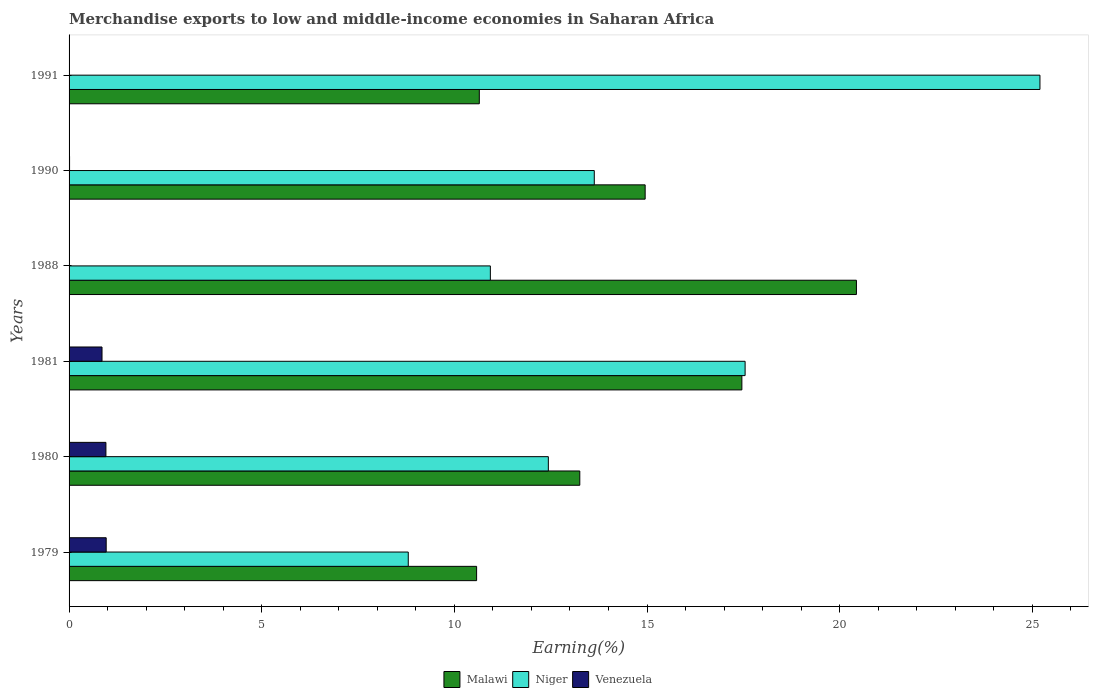Are the number of bars per tick equal to the number of legend labels?
Make the answer very short. Yes. What is the label of the 2nd group of bars from the top?
Ensure brevity in your answer.  1990. In how many cases, is the number of bars for a given year not equal to the number of legend labels?
Give a very brief answer. 0. What is the percentage of amount earned from merchandise exports in Niger in 1979?
Offer a terse response. 8.8. Across all years, what is the maximum percentage of amount earned from merchandise exports in Venezuela?
Your response must be concise. 0.96. Across all years, what is the minimum percentage of amount earned from merchandise exports in Niger?
Keep it short and to the point. 8.8. In which year was the percentage of amount earned from merchandise exports in Niger maximum?
Your response must be concise. 1991. In which year was the percentage of amount earned from merchandise exports in Niger minimum?
Provide a succinct answer. 1979. What is the total percentage of amount earned from merchandise exports in Venezuela in the graph?
Keep it short and to the point. 2.79. What is the difference between the percentage of amount earned from merchandise exports in Niger in 1980 and that in 1991?
Your answer should be very brief. -12.76. What is the difference between the percentage of amount earned from merchandise exports in Venezuela in 1990 and the percentage of amount earned from merchandise exports in Malawi in 1991?
Provide a short and direct response. -10.63. What is the average percentage of amount earned from merchandise exports in Venezuela per year?
Give a very brief answer. 0.46. In the year 1991, what is the difference between the percentage of amount earned from merchandise exports in Venezuela and percentage of amount earned from merchandise exports in Malawi?
Your answer should be very brief. -10.65. In how many years, is the percentage of amount earned from merchandise exports in Venezuela greater than 20 %?
Offer a very short reply. 0. What is the ratio of the percentage of amount earned from merchandise exports in Niger in 1980 to that in 1988?
Provide a short and direct response. 1.14. Is the percentage of amount earned from merchandise exports in Venezuela in 1979 less than that in 1988?
Ensure brevity in your answer.  No. Is the difference between the percentage of amount earned from merchandise exports in Venezuela in 1988 and 1991 greater than the difference between the percentage of amount earned from merchandise exports in Malawi in 1988 and 1991?
Keep it short and to the point. No. What is the difference between the highest and the second highest percentage of amount earned from merchandise exports in Niger?
Make the answer very short. 7.65. What is the difference between the highest and the lowest percentage of amount earned from merchandise exports in Niger?
Make the answer very short. 16.39. Is the sum of the percentage of amount earned from merchandise exports in Malawi in 1981 and 1988 greater than the maximum percentage of amount earned from merchandise exports in Venezuela across all years?
Offer a very short reply. Yes. What does the 2nd bar from the top in 1988 represents?
Provide a short and direct response. Niger. What does the 1st bar from the bottom in 1981 represents?
Give a very brief answer. Malawi. Is it the case that in every year, the sum of the percentage of amount earned from merchandise exports in Malawi and percentage of amount earned from merchandise exports in Venezuela is greater than the percentage of amount earned from merchandise exports in Niger?
Your answer should be very brief. No. How many bars are there?
Your answer should be very brief. 18. Does the graph contain any zero values?
Keep it short and to the point. No. Does the graph contain grids?
Keep it short and to the point. No. Where does the legend appear in the graph?
Offer a terse response. Bottom center. What is the title of the graph?
Offer a terse response. Merchandise exports to low and middle-income economies in Saharan Africa. What is the label or title of the X-axis?
Offer a very short reply. Earning(%). What is the label or title of the Y-axis?
Make the answer very short. Years. What is the Earning(%) of Malawi in 1979?
Make the answer very short. 10.58. What is the Earning(%) of Niger in 1979?
Keep it short and to the point. 8.8. What is the Earning(%) of Venezuela in 1979?
Give a very brief answer. 0.96. What is the Earning(%) of Malawi in 1980?
Keep it short and to the point. 13.26. What is the Earning(%) of Niger in 1980?
Offer a very short reply. 12.44. What is the Earning(%) in Venezuela in 1980?
Make the answer very short. 0.96. What is the Earning(%) of Malawi in 1981?
Offer a terse response. 17.46. What is the Earning(%) in Niger in 1981?
Ensure brevity in your answer.  17.55. What is the Earning(%) in Venezuela in 1981?
Give a very brief answer. 0.85. What is the Earning(%) of Malawi in 1988?
Offer a very short reply. 20.44. What is the Earning(%) in Niger in 1988?
Provide a short and direct response. 10.93. What is the Earning(%) of Venezuela in 1988?
Offer a very short reply. 0. What is the Earning(%) in Malawi in 1990?
Your answer should be compact. 14.95. What is the Earning(%) in Niger in 1990?
Offer a very short reply. 13.63. What is the Earning(%) of Venezuela in 1990?
Your answer should be very brief. 0.01. What is the Earning(%) of Malawi in 1991?
Keep it short and to the point. 10.65. What is the Earning(%) in Niger in 1991?
Provide a short and direct response. 25.2. What is the Earning(%) in Venezuela in 1991?
Provide a succinct answer. 0. Across all years, what is the maximum Earning(%) in Malawi?
Ensure brevity in your answer.  20.44. Across all years, what is the maximum Earning(%) in Niger?
Your answer should be compact. 25.2. Across all years, what is the maximum Earning(%) of Venezuela?
Your answer should be very brief. 0.96. Across all years, what is the minimum Earning(%) of Malawi?
Your response must be concise. 10.58. Across all years, what is the minimum Earning(%) in Niger?
Offer a very short reply. 8.8. Across all years, what is the minimum Earning(%) in Venezuela?
Offer a very short reply. 0. What is the total Earning(%) of Malawi in the graph?
Ensure brevity in your answer.  87.33. What is the total Earning(%) of Niger in the graph?
Offer a very short reply. 88.55. What is the total Earning(%) in Venezuela in the graph?
Your answer should be very brief. 2.79. What is the difference between the Earning(%) of Malawi in 1979 and that in 1980?
Provide a succinct answer. -2.68. What is the difference between the Earning(%) of Niger in 1979 and that in 1980?
Ensure brevity in your answer.  -3.64. What is the difference between the Earning(%) in Venezuela in 1979 and that in 1980?
Provide a succinct answer. 0.01. What is the difference between the Earning(%) of Malawi in 1979 and that in 1981?
Your answer should be very brief. -6.88. What is the difference between the Earning(%) of Niger in 1979 and that in 1981?
Provide a short and direct response. -8.74. What is the difference between the Earning(%) of Venezuela in 1979 and that in 1981?
Make the answer very short. 0.11. What is the difference between the Earning(%) of Malawi in 1979 and that in 1988?
Give a very brief answer. -9.86. What is the difference between the Earning(%) in Niger in 1979 and that in 1988?
Offer a terse response. -2.13. What is the difference between the Earning(%) in Venezuela in 1979 and that in 1988?
Offer a very short reply. 0.96. What is the difference between the Earning(%) in Malawi in 1979 and that in 1990?
Provide a short and direct response. -4.37. What is the difference between the Earning(%) of Niger in 1979 and that in 1990?
Keep it short and to the point. -4.83. What is the difference between the Earning(%) in Venezuela in 1979 and that in 1990?
Ensure brevity in your answer.  0.95. What is the difference between the Earning(%) in Malawi in 1979 and that in 1991?
Your response must be concise. -0.07. What is the difference between the Earning(%) of Niger in 1979 and that in 1991?
Keep it short and to the point. -16.39. What is the difference between the Earning(%) in Venezuela in 1979 and that in 1991?
Offer a terse response. 0.96. What is the difference between the Earning(%) of Malawi in 1980 and that in 1981?
Offer a terse response. -4.21. What is the difference between the Earning(%) of Niger in 1980 and that in 1981?
Make the answer very short. -5.11. What is the difference between the Earning(%) in Venezuela in 1980 and that in 1981?
Provide a short and direct response. 0.1. What is the difference between the Earning(%) of Malawi in 1980 and that in 1988?
Your answer should be very brief. -7.18. What is the difference between the Earning(%) in Niger in 1980 and that in 1988?
Your answer should be compact. 1.51. What is the difference between the Earning(%) of Venezuela in 1980 and that in 1988?
Offer a terse response. 0.96. What is the difference between the Earning(%) in Malawi in 1980 and that in 1990?
Ensure brevity in your answer.  -1.7. What is the difference between the Earning(%) of Niger in 1980 and that in 1990?
Keep it short and to the point. -1.19. What is the difference between the Earning(%) in Venezuela in 1980 and that in 1990?
Make the answer very short. 0.94. What is the difference between the Earning(%) in Malawi in 1980 and that in 1991?
Provide a succinct answer. 2.61. What is the difference between the Earning(%) in Niger in 1980 and that in 1991?
Your answer should be very brief. -12.76. What is the difference between the Earning(%) of Venezuela in 1980 and that in 1991?
Give a very brief answer. 0.96. What is the difference between the Earning(%) in Malawi in 1981 and that in 1988?
Give a very brief answer. -2.97. What is the difference between the Earning(%) in Niger in 1981 and that in 1988?
Your answer should be compact. 6.61. What is the difference between the Earning(%) of Venezuela in 1981 and that in 1988?
Your response must be concise. 0.85. What is the difference between the Earning(%) in Malawi in 1981 and that in 1990?
Your answer should be compact. 2.51. What is the difference between the Earning(%) in Niger in 1981 and that in 1990?
Provide a short and direct response. 3.91. What is the difference between the Earning(%) in Venezuela in 1981 and that in 1990?
Keep it short and to the point. 0.84. What is the difference between the Earning(%) in Malawi in 1981 and that in 1991?
Your answer should be compact. 6.81. What is the difference between the Earning(%) in Niger in 1981 and that in 1991?
Make the answer very short. -7.65. What is the difference between the Earning(%) of Venezuela in 1981 and that in 1991?
Ensure brevity in your answer.  0.85. What is the difference between the Earning(%) of Malawi in 1988 and that in 1990?
Give a very brief answer. 5.48. What is the difference between the Earning(%) in Niger in 1988 and that in 1990?
Your answer should be compact. -2.7. What is the difference between the Earning(%) in Venezuela in 1988 and that in 1990?
Make the answer very short. -0.01. What is the difference between the Earning(%) in Malawi in 1988 and that in 1991?
Make the answer very short. 9.79. What is the difference between the Earning(%) in Niger in 1988 and that in 1991?
Make the answer very short. -14.26. What is the difference between the Earning(%) in Venezuela in 1988 and that in 1991?
Keep it short and to the point. -0. What is the difference between the Earning(%) in Malawi in 1990 and that in 1991?
Give a very brief answer. 4.3. What is the difference between the Earning(%) of Niger in 1990 and that in 1991?
Ensure brevity in your answer.  -11.57. What is the difference between the Earning(%) of Venezuela in 1990 and that in 1991?
Your answer should be very brief. 0.01. What is the difference between the Earning(%) of Malawi in 1979 and the Earning(%) of Niger in 1980?
Offer a very short reply. -1.86. What is the difference between the Earning(%) of Malawi in 1979 and the Earning(%) of Venezuela in 1980?
Offer a terse response. 9.62. What is the difference between the Earning(%) of Niger in 1979 and the Earning(%) of Venezuela in 1980?
Your response must be concise. 7.85. What is the difference between the Earning(%) of Malawi in 1979 and the Earning(%) of Niger in 1981?
Ensure brevity in your answer.  -6.97. What is the difference between the Earning(%) of Malawi in 1979 and the Earning(%) of Venezuela in 1981?
Provide a succinct answer. 9.72. What is the difference between the Earning(%) in Niger in 1979 and the Earning(%) in Venezuela in 1981?
Your answer should be very brief. 7.95. What is the difference between the Earning(%) in Malawi in 1979 and the Earning(%) in Niger in 1988?
Provide a succinct answer. -0.36. What is the difference between the Earning(%) of Malawi in 1979 and the Earning(%) of Venezuela in 1988?
Your answer should be very brief. 10.58. What is the difference between the Earning(%) in Niger in 1979 and the Earning(%) in Venezuela in 1988?
Make the answer very short. 8.8. What is the difference between the Earning(%) of Malawi in 1979 and the Earning(%) of Niger in 1990?
Offer a terse response. -3.05. What is the difference between the Earning(%) of Malawi in 1979 and the Earning(%) of Venezuela in 1990?
Your answer should be very brief. 10.56. What is the difference between the Earning(%) of Niger in 1979 and the Earning(%) of Venezuela in 1990?
Provide a short and direct response. 8.79. What is the difference between the Earning(%) of Malawi in 1979 and the Earning(%) of Niger in 1991?
Your answer should be compact. -14.62. What is the difference between the Earning(%) in Malawi in 1979 and the Earning(%) in Venezuela in 1991?
Provide a short and direct response. 10.58. What is the difference between the Earning(%) in Niger in 1979 and the Earning(%) in Venezuela in 1991?
Keep it short and to the point. 8.8. What is the difference between the Earning(%) of Malawi in 1980 and the Earning(%) of Niger in 1981?
Offer a terse response. -4.29. What is the difference between the Earning(%) in Malawi in 1980 and the Earning(%) in Venezuela in 1981?
Provide a short and direct response. 12.4. What is the difference between the Earning(%) in Niger in 1980 and the Earning(%) in Venezuela in 1981?
Make the answer very short. 11.58. What is the difference between the Earning(%) in Malawi in 1980 and the Earning(%) in Niger in 1988?
Make the answer very short. 2.32. What is the difference between the Earning(%) of Malawi in 1980 and the Earning(%) of Venezuela in 1988?
Your answer should be very brief. 13.26. What is the difference between the Earning(%) in Niger in 1980 and the Earning(%) in Venezuela in 1988?
Keep it short and to the point. 12.44. What is the difference between the Earning(%) in Malawi in 1980 and the Earning(%) in Niger in 1990?
Your answer should be compact. -0.38. What is the difference between the Earning(%) of Malawi in 1980 and the Earning(%) of Venezuela in 1990?
Your answer should be very brief. 13.24. What is the difference between the Earning(%) of Niger in 1980 and the Earning(%) of Venezuela in 1990?
Provide a short and direct response. 12.43. What is the difference between the Earning(%) in Malawi in 1980 and the Earning(%) in Niger in 1991?
Your response must be concise. -11.94. What is the difference between the Earning(%) of Malawi in 1980 and the Earning(%) of Venezuela in 1991?
Make the answer very short. 13.26. What is the difference between the Earning(%) of Niger in 1980 and the Earning(%) of Venezuela in 1991?
Make the answer very short. 12.44. What is the difference between the Earning(%) in Malawi in 1981 and the Earning(%) in Niger in 1988?
Provide a short and direct response. 6.53. What is the difference between the Earning(%) in Malawi in 1981 and the Earning(%) in Venezuela in 1988?
Your response must be concise. 17.46. What is the difference between the Earning(%) in Niger in 1981 and the Earning(%) in Venezuela in 1988?
Your response must be concise. 17.55. What is the difference between the Earning(%) in Malawi in 1981 and the Earning(%) in Niger in 1990?
Your response must be concise. 3.83. What is the difference between the Earning(%) in Malawi in 1981 and the Earning(%) in Venezuela in 1990?
Give a very brief answer. 17.45. What is the difference between the Earning(%) in Niger in 1981 and the Earning(%) in Venezuela in 1990?
Your answer should be very brief. 17.53. What is the difference between the Earning(%) of Malawi in 1981 and the Earning(%) of Niger in 1991?
Keep it short and to the point. -7.74. What is the difference between the Earning(%) of Malawi in 1981 and the Earning(%) of Venezuela in 1991?
Make the answer very short. 17.46. What is the difference between the Earning(%) in Niger in 1981 and the Earning(%) in Venezuela in 1991?
Ensure brevity in your answer.  17.55. What is the difference between the Earning(%) in Malawi in 1988 and the Earning(%) in Niger in 1990?
Keep it short and to the point. 6.8. What is the difference between the Earning(%) of Malawi in 1988 and the Earning(%) of Venezuela in 1990?
Keep it short and to the point. 20.42. What is the difference between the Earning(%) of Niger in 1988 and the Earning(%) of Venezuela in 1990?
Offer a very short reply. 10.92. What is the difference between the Earning(%) of Malawi in 1988 and the Earning(%) of Niger in 1991?
Your answer should be very brief. -4.76. What is the difference between the Earning(%) of Malawi in 1988 and the Earning(%) of Venezuela in 1991?
Your answer should be compact. 20.44. What is the difference between the Earning(%) in Niger in 1988 and the Earning(%) in Venezuela in 1991?
Give a very brief answer. 10.93. What is the difference between the Earning(%) of Malawi in 1990 and the Earning(%) of Niger in 1991?
Ensure brevity in your answer.  -10.25. What is the difference between the Earning(%) in Malawi in 1990 and the Earning(%) in Venezuela in 1991?
Make the answer very short. 14.95. What is the difference between the Earning(%) of Niger in 1990 and the Earning(%) of Venezuela in 1991?
Provide a short and direct response. 13.63. What is the average Earning(%) in Malawi per year?
Keep it short and to the point. 14.55. What is the average Earning(%) in Niger per year?
Ensure brevity in your answer.  14.76. What is the average Earning(%) in Venezuela per year?
Offer a terse response. 0.46. In the year 1979, what is the difference between the Earning(%) in Malawi and Earning(%) in Niger?
Your response must be concise. 1.77. In the year 1979, what is the difference between the Earning(%) of Malawi and Earning(%) of Venezuela?
Offer a very short reply. 9.61. In the year 1979, what is the difference between the Earning(%) of Niger and Earning(%) of Venezuela?
Your answer should be very brief. 7.84. In the year 1980, what is the difference between the Earning(%) in Malawi and Earning(%) in Niger?
Make the answer very short. 0.82. In the year 1980, what is the difference between the Earning(%) in Malawi and Earning(%) in Venezuela?
Make the answer very short. 12.3. In the year 1980, what is the difference between the Earning(%) in Niger and Earning(%) in Venezuela?
Offer a very short reply. 11.48. In the year 1981, what is the difference between the Earning(%) in Malawi and Earning(%) in Niger?
Your answer should be very brief. -0.08. In the year 1981, what is the difference between the Earning(%) of Malawi and Earning(%) of Venezuela?
Give a very brief answer. 16.61. In the year 1981, what is the difference between the Earning(%) of Niger and Earning(%) of Venezuela?
Your answer should be compact. 16.69. In the year 1988, what is the difference between the Earning(%) in Malawi and Earning(%) in Niger?
Ensure brevity in your answer.  9.5. In the year 1988, what is the difference between the Earning(%) in Malawi and Earning(%) in Venezuela?
Give a very brief answer. 20.44. In the year 1988, what is the difference between the Earning(%) in Niger and Earning(%) in Venezuela?
Keep it short and to the point. 10.93. In the year 1990, what is the difference between the Earning(%) in Malawi and Earning(%) in Niger?
Offer a terse response. 1.32. In the year 1990, what is the difference between the Earning(%) in Malawi and Earning(%) in Venezuela?
Provide a succinct answer. 14.94. In the year 1990, what is the difference between the Earning(%) of Niger and Earning(%) of Venezuela?
Your response must be concise. 13.62. In the year 1991, what is the difference between the Earning(%) of Malawi and Earning(%) of Niger?
Provide a short and direct response. -14.55. In the year 1991, what is the difference between the Earning(%) of Malawi and Earning(%) of Venezuela?
Make the answer very short. 10.65. In the year 1991, what is the difference between the Earning(%) of Niger and Earning(%) of Venezuela?
Your answer should be compact. 25.2. What is the ratio of the Earning(%) in Malawi in 1979 to that in 1980?
Give a very brief answer. 0.8. What is the ratio of the Earning(%) of Niger in 1979 to that in 1980?
Provide a succinct answer. 0.71. What is the ratio of the Earning(%) of Venezuela in 1979 to that in 1980?
Provide a succinct answer. 1.01. What is the ratio of the Earning(%) in Malawi in 1979 to that in 1981?
Offer a very short reply. 0.61. What is the ratio of the Earning(%) in Niger in 1979 to that in 1981?
Your response must be concise. 0.5. What is the ratio of the Earning(%) in Venezuela in 1979 to that in 1981?
Offer a terse response. 1.13. What is the ratio of the Earning(%) in Malawi in 1979 to that in 1988?
Offer a terse response. 0.52. What is the ratio of the Earning(%) of Niger in 1979 to that in 1988?
Give a very brief answer. 0.81. What is the ratio of the Earning(%) in Venezuela in 1979 to that in 1988?
Make the answer very short. 4655.71. What is the ratio of the Earning(%) of Malawi in 1979 to that in 1990?
Give a very brief answer. 0.71. What is the ratio of the Earning(%) of Niger in 1979 to that in 1990?
Make the answer very short. 0.65. What is the ratio of the Earning(%) of Venezuela in 1979 to that in 1990?
Your answer should be compact. 75.58. What is the ratio of the Earning(%) of Malawi in 1979 to that in 1991?
Ensure brevity in your answer.  0.99. What is the ratio of the Earning(%) of Niger in 1979 to that in 1991?
Make the answer very short. 0.35. What is the ratio of the Earning(%) of Venezuela in 1979 to that in 1991?
Offer a terse response. 3747.52. What is the ratio of the Earning(%) in Malawi in 1980 to that in 1981?
Offer a terse response. 0.76. What is the ratio of the Earning(%) in Niger in 1980 to that in 1981?
Ensure brevity in your answer.  0.71. What is the ratio of the Earning(%) of Venezuela in 1980 to that in 1981?
Offer a terse response. 1.12. What is the ratio of the Earning(%) in Malawi in 1980 to that in 1988?
Provide a succinct answer. 0.65. What is the ratio of the Earning(%) in Niger in 1980 to that in 1988?
Your answer should be compact. 1.14. What is the ratio of the Earning(%) in Venezuela in 1980 to that in 1988?
Make the answer very short. 4621.52. What is the ratio of the Earning(%) in Malawi in 1980 to that in 1990?
Your answer should be very brief. 0.89. What is the ratio of the Earning(%) in Niger in 1980 to that in 1990?
Provide a short and direct response. 0.91. What is the ratio of the Earning(%) of Venezuela in 1980 to that in 1990?
Your answer should be very brief. 75.03. What is the ratio of the Earning(%) of Malawi in 1980 to that in 1991?
Keep it short and to the point. 1.24. What is the ratio of the Earning(%) in Niger in 1980 to that in 1991?
Offer a very short reply. 0.49. What is the ratio of the Earning(%) of Venezuela in 1980 to that in 1991?
Provide a succinct answer. 3719.99. What is the ratio of the Earning(%) of Malawi in 1981 to that in 1988?
Your answer should be very brief. 0.85. What is the ratio of the Earning(%) of Niger in 1981 to that in 1988?
Provide a succinct answer. 1.6. What is the ratio of the Earning(%) in Venezuela in 1981 to that in 1988?
Keep it short and to the point. 4131.37. What is the ratio of the Earning(%) of Malawi in 1981 to that in 1990?
Your response must be concise. 1.17. What is the ratio of the Earning(%) of Niger in 1981 to that in 1990?
Your answer should be very brief. 1.29. What is the ratio of the Earning(%) of Venezuela in 1981 to that in 1990?
Your answer should be very brief. 67.07. What is the ratio of the Earning(%) in Malawi in 1981 to that in 1991?
Keep it short and to the point. 1.64. What is the ratio of the Earning(%) of Niger in 1981 to that in 1991?
Offer a very short reply. 0.7. What is the ratio of the Earning(%) of Venezuela in 1981 to that in 1991?
Offer a terse response. 3325.46. What is the ratio of the Earning(%) of Malawi in 1988 to that in 1990?
Keep it short and to the point. 1.37. What is the ratio of the Earning(%) in Niger in 1988 to that in 1990?
Provide a short and direct response. 0.8. What is the ratio of the Earning(%) in Venezuela in 1988 to that in 1990?
Make the answer very short. 0.02. What is the ratio of the Earning(%) of Malawi in 1988 to that in 1991?
Ensure brevity in your answer.  1.92. What is the ratio of the Earning(%) in Niger in 1988 to that in 1991?
Your answer should be compact. 0.43. What is the ratio of the Earning(%) of Venezuela in 1988 to that in 1991?
Provide a succinct answer. 0.8. What is the ratio of the Earning(%) in Malawi in 1990 to that in 1991?
Keep it short and to the point. 1.4. What is the ratio of the Earning(%) of Niger in 1990 to that in 1991?
Your answer should be very brief. 0.54. What is the ratio of the Earning(%) of Venezuela in 1990 to that in 1991?
Offer a terse response. 49.58. What is the difference between the highest and the second highest Earning(%) in Malawi?
Offer a very short reply. 2.97. What is the difference between the highest and the second highest Earning(%) of Niger?
Your response must be concise. 7.65. What is the difference between the highest and the second highest Earning(%) of Venezuela?
Your answer should be compact. 0.01. What is the difference between the highest and the lowest Earning(%) of Malawi?
Offer a terse response. 9.86. What is the difference between the highest and the lowest Earning(%) in Niger?
Provide a succinct answer. 16.39. What is the difference between the highest and the lowest Earning(%) of Venezuela?
Offer a very short reply. 0.96. 